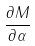Convert formula to latex. <formula><loc_0><loc_0><loc_500><loc_500>\frac { \partial M } { \partial \alpha }</formula> 